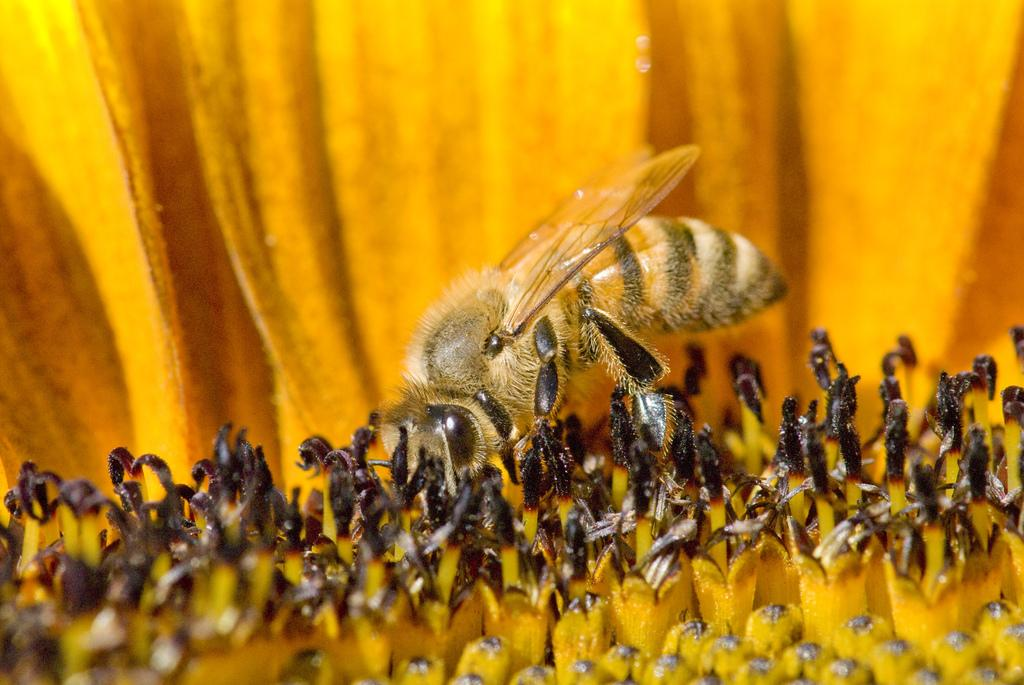What type of insect is present in the image? There is a honeybee in the image. What is the honeybee interacting with in the image? The honeybee is interacting with a flower in the image. What type of hair is visible on the honeybee in the image? There is no hair visible on the honeybee in the image, as honeybees do not have hair like mammals. 